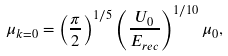<formula> <loc_0><loc_0><loc_500><loc_500>\mu _ { k = 0 } = \left ( \frac { \pi } { 2 } \right ) ^ { 1 / 5 } \left ( \frac { U _ { 0 } } { E _ { r e c } } \right ) ^ { 1 / 1 0 } \mu _ { 0 } ,</formula> 